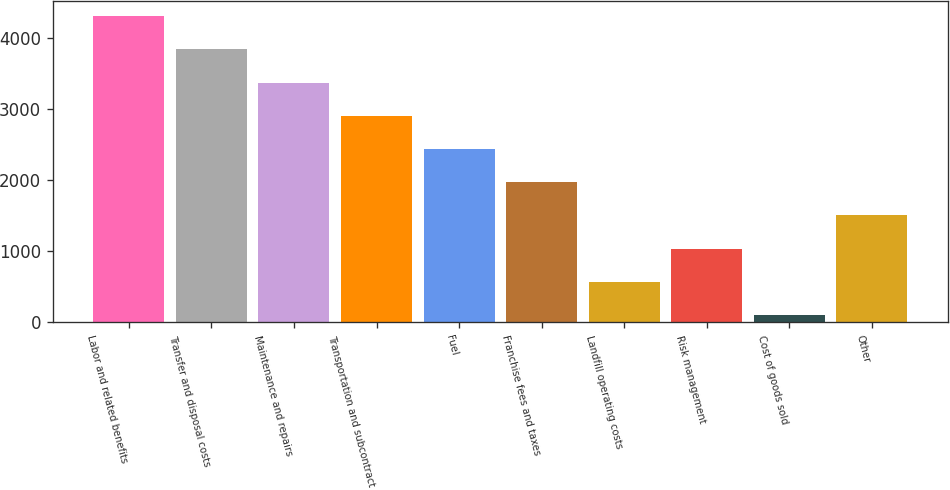Convert chart. <chart><loc_0><loc_0><loc_500><loc_500><bar_chart><fcel>Labor and related benefits<fcel>Transfer and disposal costs<fcel>Maintenance and repairs<fcel>Transportation and subcontract<fcel>Fuel<fcel>Franchise fees and taxes<fcel>Landfill operating costs<fcel>Risk management<fcel>Cost of goods sold<fcel>Other<nl><fcel>4298.71<fcel>3832.62<fcel>3366.53<fcel>2900.44<fcel>2434.35<fcel>1968.26<fcel>569.99<fcel>1036.08<fcel>103.9<fcel>1502.17<nl></chart> 